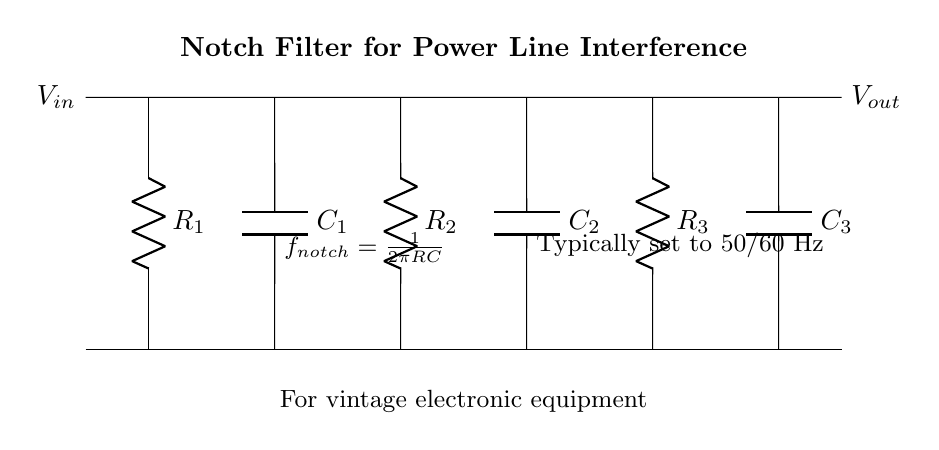What is the purpose of this circuit? This circuit is designed to filter out power line interference, specifically for vintage electronic equipment. Notch filters are used to eliminate specific frequency signals without affecting other frequencies, which is crucial in preserving the integrity of the audio or signal quality in older devices.
Answer: Eliminate power line interference How many resistors are in the circuit? There are three resistors labeled R1, R2, and R3 connected in the circuit. Each component is distinctly shown, and counting the resistors leads to this total.
Answer: Three What is the formula for the notch frequency? The notch frequency is given by the formula: f noth = 1/(2πRC). This is provided directly in the diagram near the capacitor connections. To derive this, it is recognized that the resonance in the filter circuit leads to this specific frequency condition, which is a fundamental property of R-C circuits.
Answer: 1/(2πRC) What are the types of components used in this circuit? The components in this circuit include resistors and capacitors. Each type is labeled accordingly, showing that it comprises both types of passive components which are essential for the filtering function of this circuit.
Answer: Resistors and capacitors At what frequency is this notch filter typically set? The typical frequency for this notch filter is set to 50 or 60 Hertz. This is a common frequency for power line interference, directly noted in the circuit diagram as it relates to global power supply standards.
Answer: 50/60 Hz What is the input voltage symbol in the circuit? The input voltage is labeled as V in, located on the left side of the circuit diagram. It designates the voltage entering the notch filter. Identifying this label leads directly to the answer.
Answer: V in 